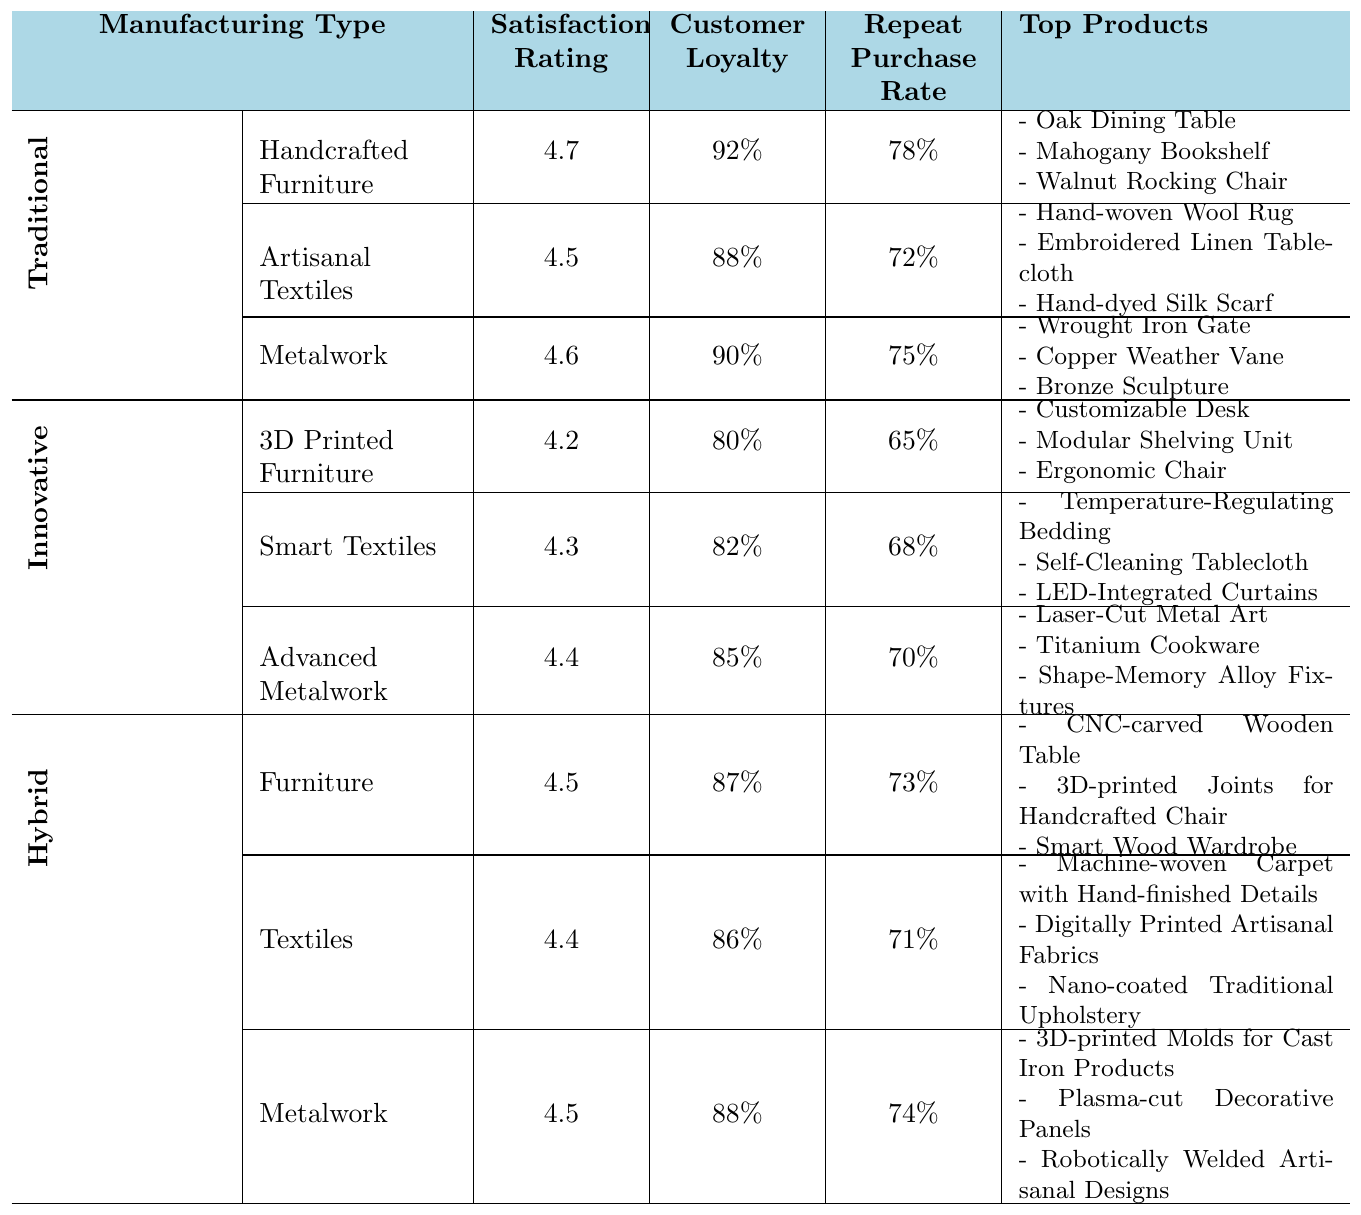What is the satisfaction rating for Handcrafted Furniture? The satisfaction rating for Handcrafted Furniture is listed directly in the table. It can be found in the Traditional Manufacturing section under Handcrafted Furniture.
Answer: 4.7 Which manufacturing type has the highest customer loyalty? To find out which manufacturing type has the highest customer loyalty, we need to look at the Customer Loyalty percentages for each type. Traditional Manufacturing has ratings of 92%, 88%, and 90%, while Innovative Manufacturing has 80%, 82%, and 85%, and Hybrid Manufacturing has values of 87%, 86%, and 88%. The highest is 92% from Traditional Manufacturing.
Answer: Traditional Manufacturing What is the average satisfaction rating for all products in Hybrid Manufacturing? The satisfaction ratings for Hybrid Manufacturing are 4.5, 4.4, and 4.5. To find the average, we sum these ratings: 4.5 + 4.4 + 4.5 = 13.4, and then divide by 3 (the number of products): 13.4 / 3 = 4.4667, which rounds to 4.47.
Answer: 4.47 Which product category has the lowest repeat purchase rate among the Innovative Manufacturing items? Looking at the Repeat Purchase Rate for each category under Innovative Manufacturing, we see 65% for 3D Printed Furniture, 68% for Smart Textiles, and 70% for Advanced Metalwork. The lowest rate is 65% for 3D Printed Furniture.
Answer: 3D Printed Furniture Is the satisfaction rating for Metalwork in Traditional Manufacturing higher than that in Innovative Manufacturing? The satisfaction rating for Metalwork in Traditional Manufacturing is 4.6, while in Innovative Manufacturing it is 4.4. Comparing these two values, 4.6 is indeed higher than 4.4.
Answer: Yes What is the difference in customer loyalty between Artisanal Textiles and Smart Textiles? Artisanal Textiles has a customer loyalty of 88%, while Smart Textiles has a customer loyalty of 82%. To find the difference: 88% - 82% = 6%.
Answer: 6% Which Hybrid Manufacturing product has the highest customer loyalty? The customer loyalty ratings for Hybrid Manufacturing are 87% for Furniture, 86% for Textiles, and 88% for Metalwork. The highest of these is 88% for Metalwork.
Answer: Metalwork How do the satisfaction ratings of Advanced Metalwork and Metalwork in Traditional Manufacturing compare? The satisfaction rating for Advanced Metalwork in Innovative Manufacturing is 4.4; for Metalwork in Traditional Manufacturing, it is 4.6. Comparing these, 4.6 is higher than 4.4, so the Traditional Manufacturing Metalwork has a higher rating.
Answer: Metalwork in Traditional Manufacturing is higher What percentage of customers are likely to make repeat purchases for Handcrafted Furniture? The Repeat Purchase Rate for Handcrafted Furniture is provided directly as 78% in the table under Traditional Manufacturing.
Answer: 78% Which category has a satisfaction rating greater than 4.5 but less than that of Handcrafted Furniture? We see that Artisanal Textiles has a rating of 4.5, and 3D Printed Furniture has a rating of 4.2. The only category meeting the criteria is Artisanal Textiles, as it is equal to 4.5 but does not exceed it.
Answer: Artisanal Textiles 